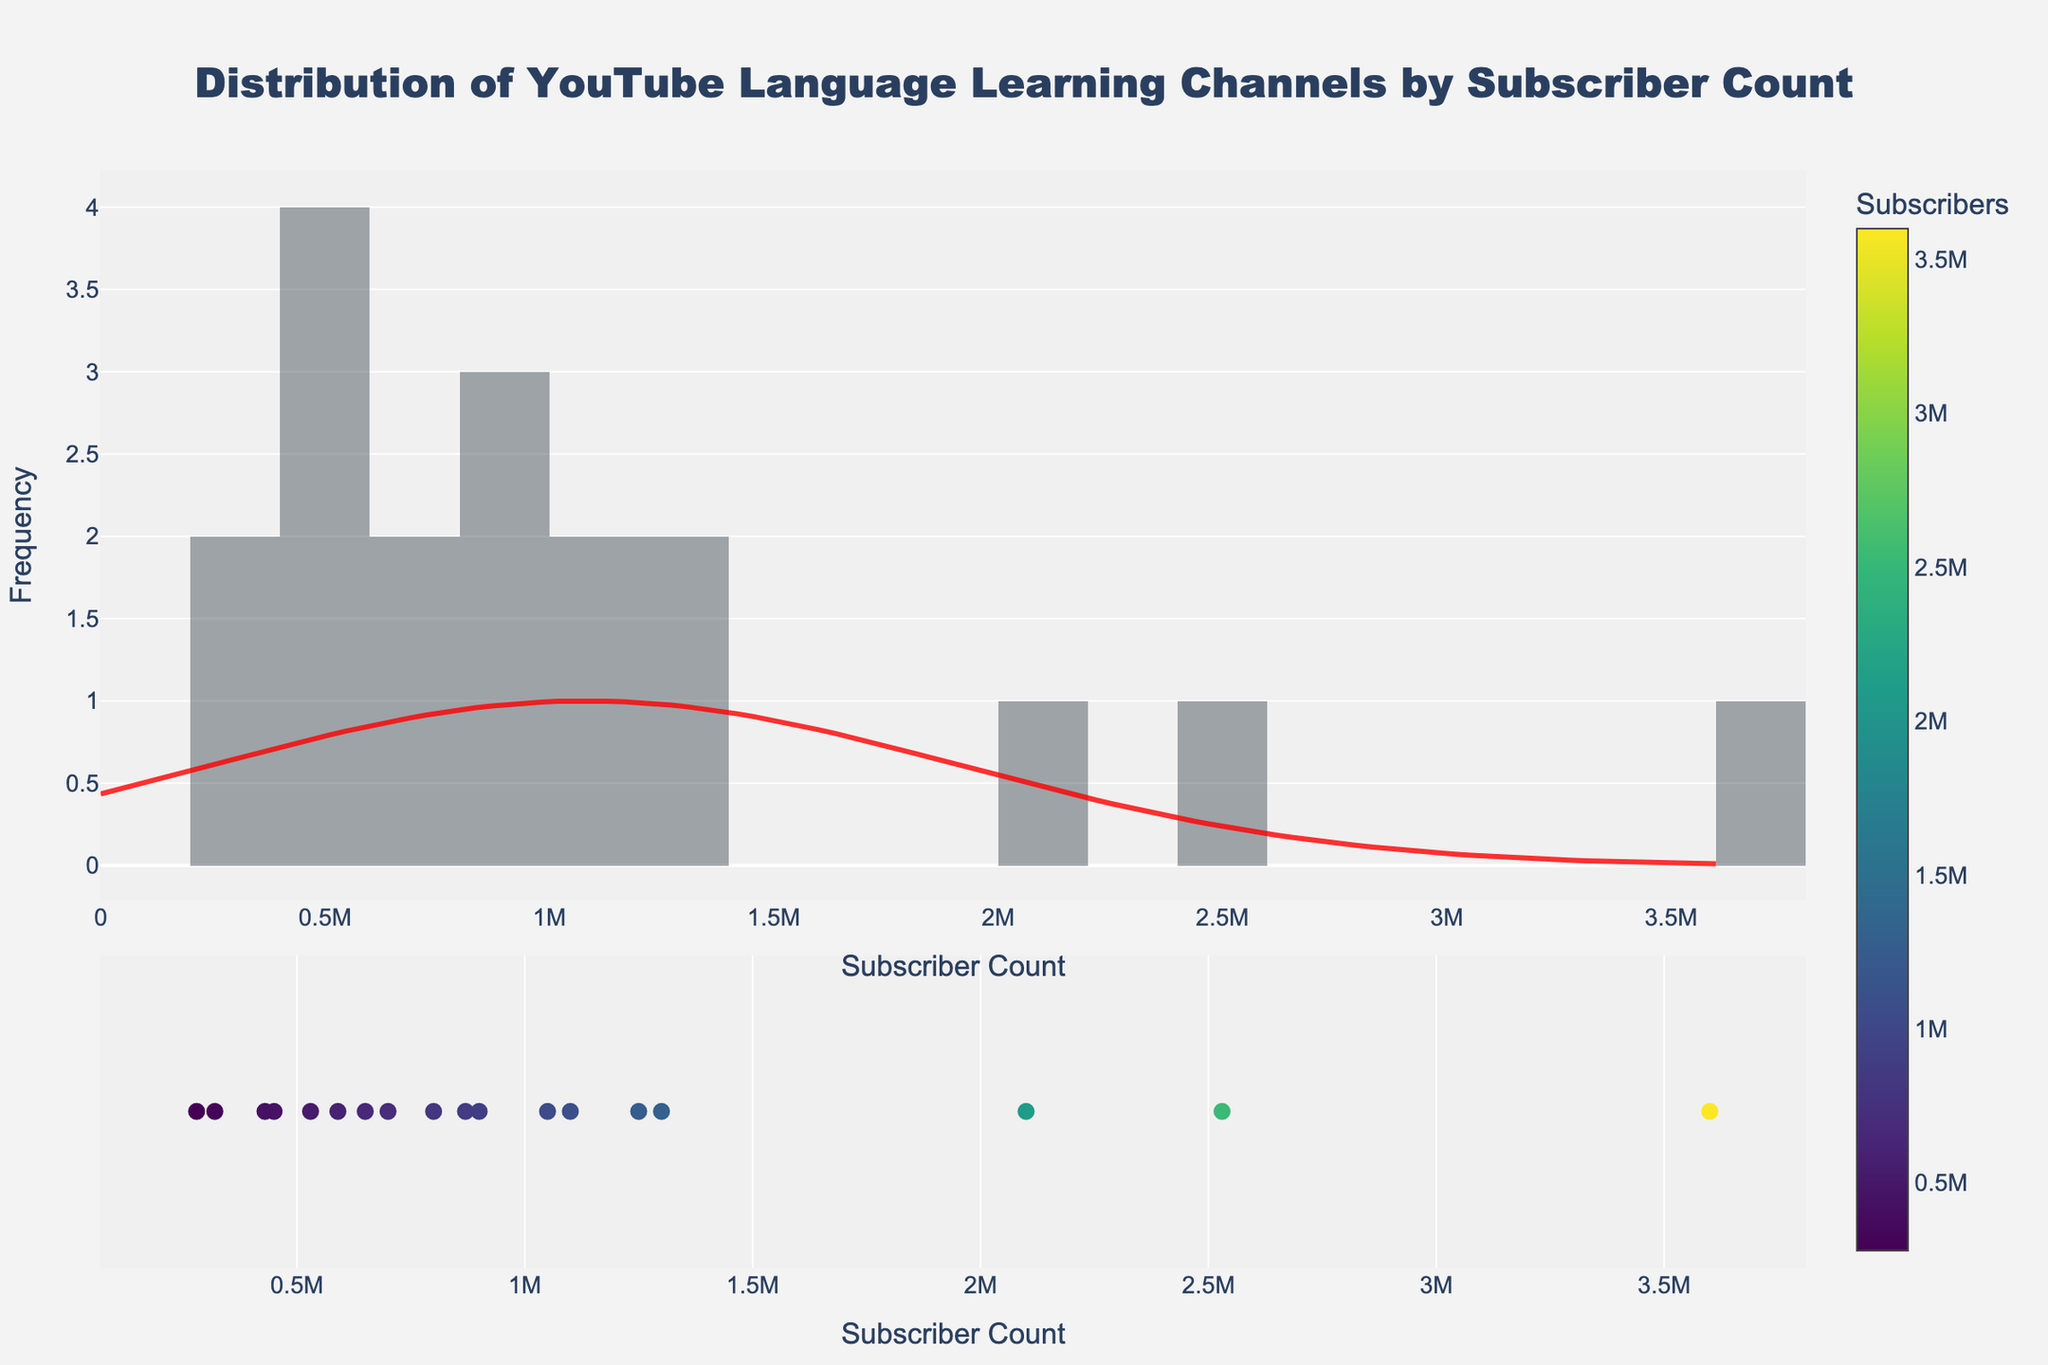What is the title of the figure? The title is prominently displayed at the top of the figure. It reads "Distribution of YouTube Language Learning Channels by Subscriber Count."
Answer: Distribution of YouTube Language Learning Channels by Subscriber Count How many bins are used in the histogram? By counting the number of bars in the histogram, we can determine the number of bins. The figure has 20 bins.
Answer: 20 Which channel has the highest subscriber count? The scatter plot at the bottom of the figure shows the subscriber count for each channel, with hover text displaying their names. "Learn English with Emma [engVid]" has the highest subscriber count.
Answer: Learn English with Emma [engVid] What is the range of subscriber counts covered in the figure? The histogram shows the lowest bin starting from 0 and the highest bin covering up to approximately 4,000,000 subscribers. Thus, the range is from 0 to about 4,000,000.
Answer: 0 to 4,000,000 Which channels fall under the 1,000,000 to 2,000,000 subscriber count in the scatter plot? By observing the scatter plot, the channels within the 1,000,000 to 2,000,000 subscriber count include: Learn German with Anja, Polyglot Stories, Learn French with Alexa, Rachel’s English.
Answer: Learn German with Anja, Polyglot Stories, Learn French with Alexa, Rachel’s English What does the KDE line represent, and where is its peak? The red KDE (Kernel Density Estimation) line represents the estimated probability density function of subscriber counts. Its peak is around 900,000 subscribers.
Answer: Estimated density function, peak at 900,000 How does the distribution of subscriber counts look according to the histogram? The histogram shows most channels have fewer than 1,000,000 subscribers, with a gradual decrease in frequency as subscriber counts increase.
Answer: Most channels have fewer than 1,000,000 subscribers Which channels have subscriber counts represented at the far right end of the KDE line? Channels at the far right end of the KDE line in the scatter plot include: Learn English with Emma [engVid], SpanishDict, Rachel’s English, which have the highest subscriber counts.
Answer: Learn English with Emma [engVid], SpanishDict, Rachel’s English How does the color scale in the scatter plot relate to subscriber counts? The color scale in the scatter plot varies from light to dark, with darker colors representing higher subscriber counts shown in the color bar.
Answer: Darker colors signify higher subscriber counts 